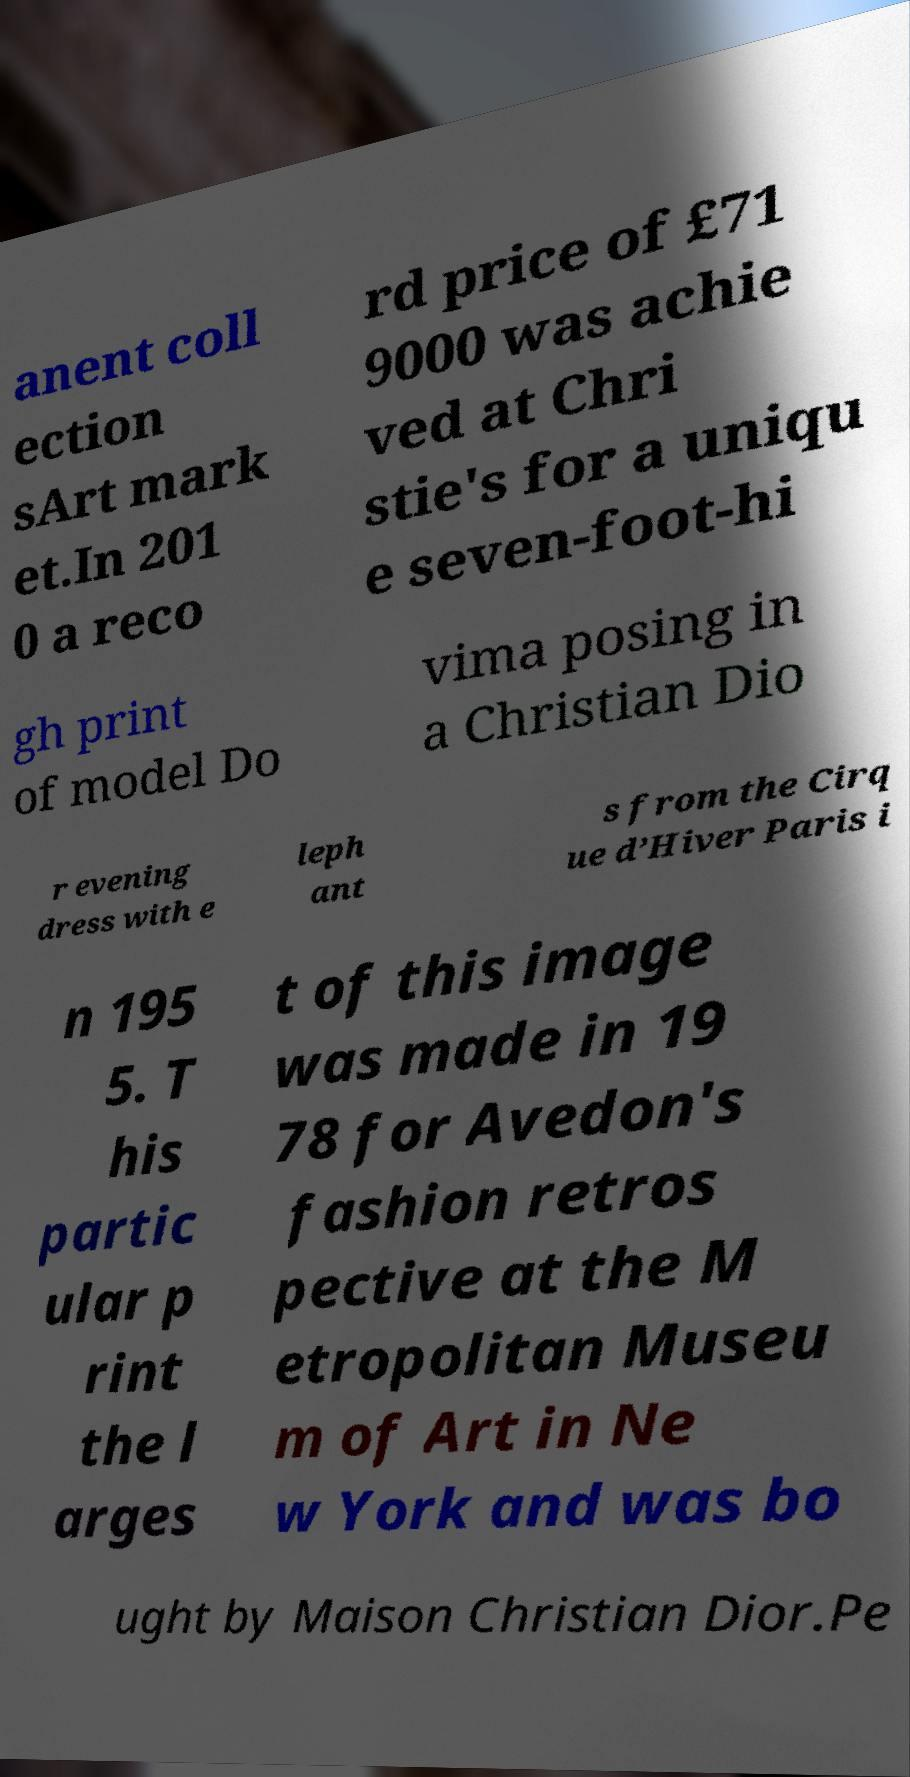Could you extract and type out the text from this image? anent coll ection sArt mark et.In 201 0 a reco rd price of £71 9000 was achie ved at Chri stie's for a uniqu e seven-foot-hi gh print of model Do vima posing in a Christian Dio r evening dress with e leph ant s from the Cirq ue d’Hiver Paris i n 195 5. T his partic ular p rint the l arges t of this image was made in 19 78 for Avedon's fashion retros pective at the M etropolitan Museu m of Art in Ne w York and was bo ught by Maison Christian Dior.Pe 